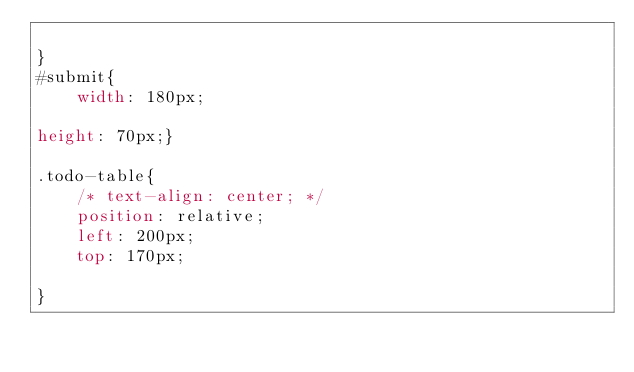<code> <loc_0><loc_0><loc_500><loc_500><_CSS_>    
}
#submit{
    width: 180px;

height: 70px;}

.todo-table{
    /* text-align: center; */
    position: relative;
    left: 200px;
    top: 170px;

}</code> 